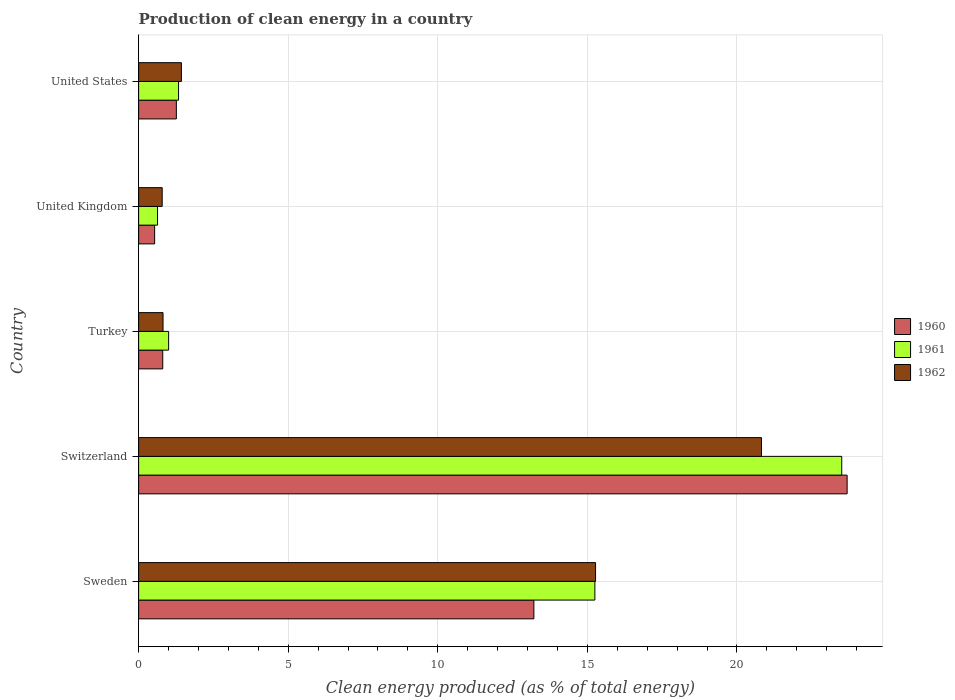How many different coloured bars are there?
Give a very brief answer. 3. Are the number of bars on each tick of the Y-axis equal?
Give a very brief answer. Yes. How many bars are there on the 4th tick from the top?
Offer a very short reply. 3. How many bars are there on the 2nd tick from the bottom?
Provide a succinct answer. 3. What is the label of the 2nd group of bars from the top?
Provide a succinct answer. United Kingdom. In how many cases, is the number of bars for a given country not equal to the number of legend labels?
Your answer should be very brief. 0. What is the percentage of clean energy produced in 1960 in United Kingdom?
Provide a short and direct response. 0.54. Across all countries, what is the maximum percentage of clean energy produced in 1961?
Provide a succinct answer. 23.5. Across all countries, what is the minimum percentage of clean energy produced in 1960?
Your response must be concise. 0.54. In which country was the percentage of clean energy produced in 1960 maximum?
Make the answer very short. Switzerland. What is the total percentage of clean energy produced in 1960 in the graph?
Your response must be concise. 39.5. What is the difference between the percentage of clean energy produced in 1962 in Sweden and that in Turkey?
Keep it short and to the point. 14.46. What is the difference between the percentage of clean energy produced in 1961 in United States and the percentage of clean energy produced in 1962 in Switzerland?
Ensure brevity in your answer.  -19.48. What is the average percentage of clean energy produced in 1960 per country?
Offer a very short reply. 7.9. What is the difference between the percentage of clean energy produced in 1962 and percentage of clean energy produced in 1961 in Switzerland?
Offer a very short reply. -2.68. In how many countries, is the percentage of clean energy produced in 1961 greater than 19 %?
Make the answer very short. 1. What is the ratio of the percentage of clean energy produced in 1961 in Sweden to that in United States?
Your answer should be compact. 11.43. What is the difference between the highest and the second highest percentage of clean energy produced in 1960?
Provide a succinct answer. 10.47. What is the difference between the highest and the lowest percentage of clean energy produced in 1960?
Offer a terse response. 23.15. In how many countries, is the percentage of clean energy produced in 1962 greater than the average percentage of clean energy produced in 1962 taken over all countries?
Provide a short and direct response. 2. Is the sum of the percentage of clean energy produced in 1960 in Sweden and United Kingdom greater than the maximum percentage of clean energy produced in 1961 across all countries?
Give a very brief answer. No. What does the 1st bar from the bottom in United States represents?
Offer a terse response. 1960. Is it the case that in every country, the sum of the percentage of clean energy produced in 1960 and percentage of clean energy produced in 1961 is greater than the percentage of clean energy produced in 1962?
Your answer should be compact. Yes. Are all the bars in the graph horizontal?
Keep it short and to the point. Yes. Are the values on the major ticks of X-axis written in scientific E-notation?
Give a very brief answer. No. Does the graph contain grids?
Your answer should be compact. Yes. How are the legend labels stacked?
Provide a succinct answer. Vertical. What is the title of the graph?
Give a very brief answer. Production of clean energy in a country. Does "1972" appear as one of the legend labels in the graph?
Keep it short and to the point. No. What is the label or title of the X-axis?
Your answer should be compact. Clean energy produced (as % of total energy). What is the label or title of the Y-axis?
Offer a very short reply. Country. What is the Clean energy produced (as % of total energy) of 1960 in Sweden?
Offer a terse response. 13.21. What is the Clean energy produced (as % of total energy) of 1961 in Sweden?
Your answer should be compact. 15.25. What is the Clean energy produced (as % of total energy) of 1962 in Sweden?
Make the answer very short. 15.27. What is the Clean energy produced (as % of total energy) in 1960 in Switzerland?
Provide a short and direct response. 23.68. What is the Clean energy produced (as % of total energy) in 1961 in Switzerland?
Your answer should be compact. 23.5. What is the Clean energy produced (as % of total energy) in 1962 in Switzerland?
Keep it short and to the point. 20.82. What is the Clean energy produced (as % of total energy) in 1960 in Turkey?
Provide a succinct answer. 0.81. What is the Clean energy produced (as % of total energy) in 1961 in Turkey?
Make the answer very short. 1. What is the Clean energy produced (as % of total energy) of 1962 in Turkey?
Ensure brevity in your answer.  0.82. What is the Clean energy produced (as % of total energy) of 1960 in United Kingdom?
Make the answer very short. 0.54. What is the Clean energy produced (as % of total energy) of 1961 in United Kingdom?
Offer a very short reply. 0.63. What is the Clean energy produced (as % of total energy) in 1962 in United Kingdom?
Make the answer very short. 0.79. What is the Clean energy produced (as % of total energy) of 1960 in United States?
Ensure brevity in your answer.  1.26. What is the Clean energy produced (as % of total energy) in 1961 in United States?
Your answer should be very brief. 1.33. What is the Clean energy produced (as % of total energy) in 1962 in United States?
Your response must be concise. 1.43. Across all countries, what is the maximum Clean energy produced (as % of total energy) in 1960?
Keep it short and to the point. 23.68. Across all countries, what is the maximum Clean energy produced (as % of total energy) of 1961?
Offer a terse response. 23.5. Across all countries, what is the maximum Clean energy produced (as % of total energy) in 1962?
Ensure brevity in your answer.  20.82. Across all countries, what is the minimum Clean energy produced (as % of total energy) of 1960?
Give a very brief answer. 0.54. Across all countries, what is the minimum Clean energy produced (as % of total energy) of 1961?
Your answer should be compact. 0.63. Across all countries, what is the minimum Clean energy produced (as % of total energy) in 1962?
Your answer should be very brief. 0.79. What is the total Clean energy produced (as % of total energy) of 1960 in the graph?
Your answer should be very brief. 39.5. What is the total Clean energy produced (as % of total energy) of 1961 in the graph?
Ensure brevity in your answer.  41.72. What is the total Clean energy produced (as % of total energy) in 1962 in the graph?
Your response must be concise. 39.12. What is the difference between the Clean energy produced (as % of total energy) in 1960 in Sweden and that in Switzerland?
Ensure brevity in your answer.  -10.47. What is the difference between the Clean energy produced (as % of total energy) in 1961 in Sweden and that in Switzerland?
Make the answer very short. -8.25. What is the difference between the Clean energy produced (as % of total energy) in 1962 in Sweden and that in Switzerland?
Provide a succinct answer. -5.55. What is the difference between the Clean energy produced (as % of total energy) of 1960 in Sweden and that in Turkey?
Provide a short and direct response. 12.4. What is the difference between the Clean energy produced (as % of total energy) of 1961 in Sweden and that in Turkey?
Offer a very short reply. 14.25. What is the difference between the Clean energy produced (as % of total energy) in 1962 in Sweden and that in Turkey?
Offer a very short reply. 14.46. What is the difference between the Clean energy produced (as % of total energy) in 1960 in Sweden and that in United Kingdom?
Offer a terse response. 12.68. What is the difference between the Clean energy produced (as % of total energy) in 1961 in Sweden and that in United Kingdom?
Offer a terse response. 14.62. What is the difference between the Clean energy produced (as % of total energy) in 1962 in Sweden and that in United Kingdom?
Make the answer very short. 14.49. What is the difference between the Clean energy produced (as % of total energy) of 1960 in Sweden and that in United States?
Keep it short and to the point. 11.95. What is the difference between the Clean energy produced (as % of total energy) of 1961 in Sweden and that in United States?
Make the answer very short. 13.92. What is the difference between the Clean energy produced (as % of total energy) in 1962 in Sweden and that in United States?
Keep it short and to the point. 13.84. What is the difference between the Clean energy produced (as % of total energy) of 1960 in Switzerland and that in Turkey?
Your response must be concise. 22.88. What is the difference between the Clean energy produced (as % of total energy) of 1961 in Switzerland and that in Turkey?
Provide a succinct answer. 22.5. What is the difference between the Clean energy produced (as % of total energy) in 1962 in Switzerland and that in Turkey?
Offer a very short reply. 20. What is the difference between the Clean energy produced (as % of total energy) in 1960 in Switzerland and that in United Kingdom?
Offer a terse response. 23.15. What is the difference between the Clean energy produced (as % of total energy) of 1961 in Switzerland and that in United Kingdom?
Your answer should be compact. 22.87. What is the difference between the Clean energy produced (as % of total energy) in 1962 in Switzerland and that in United Kingdom?
Offer a terse response. 20.03. What is the difference between the Clean energy produced (as % of total energy) of 1960 in Switzerland and that in United States?
Your answer should be compact. 22.42. What is the difference between the Clean energy produced (as % of total energy) in 1961 in Switzerland and that in United States?
Your answer should be compact. 22.17. What is the difference between the Clean energy produced (as % of total energy) of 1962 in Switzerland and that in United States?
Give a very brief answer. 19.39. What is the difference between the Clean energy produced (as % of total energy) of 1960 in Turkey and that in United Kingdom?
Provide a short and direct response. 0.27. What is the difference between the Clean energy produced (as % of total energy) of 1961 in Turkey and that in United Kingdom?
Offer a very short reply. 0.37. What is the difference between the Clean energy produced (as % of total energy) in 1962 in Turkey and that in United Kingdom?
Your answer should be compact. 0.03. What is the difference between the Clean energy produced (as % of total energy) in 1960 in Turkey and that in United States?
Make the answer very short. -0.46. What is the difference between the Clean energy produced (as % of total energy) in 1961 in Turkey and that in United States?
Your answer should be compact. -0.33. What is the difference between the Clean energy produced (as % of total energy) of 1962 in Turkey and that in United States?
Offer a terse response. -0.61. What is the difference between the Clean energy produced (as % of total energy) of 1960 in United Kingdom and that in United States?
Provide a short and direct response. -0.73. What is the difference between the Clean energy produced (as % of total energy) of 1961 in United Kingdom and that in United States?
Offer a terse response. -0.7. What is the difference between the Clean energy produced (as % of total energy) in 1962 in United Kingdom and that in United States?
Make the answer very short. -0.64. What is the difference between the Clean energy produced (as % of total energy) of 1960 in Sweden and the Clean energy produced (as % of total energy) of 1961 in Switzerland?
Your response must be concise. -10.29. What is the difference between the Clean energy produced (as % of total energy) in 1960 in Sweden and the Clean energy produced (as % of total energy) in 1962 in Switzerland?
Provide a short and direct response. -7.61. What is the difference between the Clean energy produced (as % of total energy) in 1961 in Sweden and the Clean energy produced (as % of total energy) in 1962 in Switzerland?
Make the answer very short. -5.57. What is the difference between the Clean energy produced (as % of total energy) of 1960 in Sweden and the Clean energy produced (as % of total energy) of 1961 in Turkey?
Keep it short and to the point. 12.21. What is the difference between the Clean energy produced (as % of total energy) of 1960 in Sweden and the Clean energy produced (as % of total energy) of 1962 in Turkey?
Offer a very short reply. 12.4. What is the difference between the Clean energy produced (as % of total energy) of 1961 in Sweden and the Clean energy produced (as % of total energy) of 1962 in Turkey?
Give a very brief answer. 14.43. What is the difference between the Clean energy produced (as % of total energy) in 1960 in Sweden and the Clean energy produced (as % of total energy) in 1961 in United Kingdom?
Your response must be concise. 12.58. What is the difference between the Clean energy produced (as % of total energy) of 1960 in Sweden and the Clean energy produced (as % of total energy) of 1962 in United Kingdom?
Ensure brevity in your answer.  12.42. What is the difference between the Clean energy produced (as % of total energy) in 1961 in Sweden and the Clean energy produced (as % of total energy) in 1962 in United Kingdom?
Your answer should be compact. 14.46. What is the difference between the Clean energy produced (as % of total energy) in 1960 in Sweden and the Clean energy produced (as % of total energy) in 1961 in United States?
Provide a succinct answer. 11.88. What is the difference between the Clean energy produced (as % of total energy) in 1960 in Sweden and the Clean energy produced (as % of total energy) in 1962 in United States?
Make the answer very short. 11.78. What is the difference between the Clean energy produced (as % of total energy) in 1961 in Sweden and the Clean energy produced (as % of total energy) in 1962 in United States?
Make the answer very short. 13.82. What is the difference between the Clean energy produced (as % of total energy) in 1960 in Switzerland and the Clean energy produced (as % of total energy) in 1961 in Turkey?
Offer a very short reply. 22.68. What is the difference between the Clean energy produced (as % of total energy) in 1960 in Switzerland and the Clean energy produced (as % of total energy) in 1962 in Turkey?
Ensure brevity in your answer.  22.87. What is the difference between the Clean energy produced (as % of total energy) in 1961 in Switzerland and the Clean energy produced (as % of total energy) in 1962 in Turkey?
Keep it short and to the point. 22.69. What is the difference between the Clean energy produced (as % of total energy) of 1960 in Switzerland and the Clean energy produced (as % of total energy) of 1961 in United Kingdom?
Your answer should be very brief. 23.05. What is the difference between the Clean energy produced (as % of total energy) in 1960 in Switzerland and the Clean energy produced (as % of total energy) in 1962 in United Kingdom?
Keep it short and to the point. 22.89. What is the difference between the Clean energy produced (as % of total energy) of 1961 in Switzerland and the Clean energy produced (as % of total energy) of 1962 in United Kingdom?
Keep it short and to the point. 22.71. What is the difference between the Clean energy produced (as % of total energy) in 1960 in Switzerland and the Clean energy produced (as % of total energy) in 1961 in United States?
Your response must be concise. 22.35. What is the difference between the Clean energy produced (as % of total energy) in 1960 in Switzerland and the Clean energy produced (as % of total energy) in 1962 in United States?
Ensure brevity in your answer.  22.25. What is the difference between the Clean energy produced (as % of total energy) of 1961 in Switzerland and the Clean energy produced (as % of total energy) of 1962 in United States?
Ensure brevity in your answer.  22.07. What is the difference between the Clean energy produced (as % of total energy) of 1960 in Turkey and the Clean energy produced (as % of total energy) of 1961 in United Kingdom?
Give a very brief answer. 0.17. What is the difference between the Clean energy produced (as % of total energy) in 1960 in Turkey and the Clean energy produced (as % of total energy) in 1962 in United Kingdom?
Give a very brief answer. 0.02. What is the difference between the Clean energy produced (as % of total energy) of 1961 in Turkey and the Clean energy produced (as % of total energy) of 1962 in United Kingdom?
Provide a succinct answer. 0.21. What is the difference between the Clean energy produced (as % of total energy) in 1960 in Turkey and the Clean energy produced (as % of total energy) in 1961 in United States?
Keep it short and to the point. -0.53. What is the difference between the Clean energy produced (as % of total energy) of 1960 in Turkey and the Clean energy produced (as % of total energy) of 1962 in United States?
Offer a terse response. -0.62. What is the difference between the Clean energy produced (as % of total energy) in 1961 in Turkey and the Clean energy produced (as % of total energy) in 1962 in United States?
Give a very brief answer. -0.43. What is the difference between the Clean energy produced (as % of total energy) of 1960 in United Kingdom and the Clean energy produced (as % of total energy) of 1961 in United States?
Provide a succinct answer. -0.8. What is the difference between the Clean energy produced (as % of total energy) of 1960 in United Kingdom and the Clean energy produced (as % of total energy) of 1962 in United States?
Your answer should be compact. -0.89. What is the difference between the Clean energy produced (as % of total energy) of 1961 in United Kingdom and the Clean energy produced (as % of total energy) of 1962 in United States?
Your answer should be very brief. -0.8. What is the average Clean energy produced (as % of total energy) in 1960 per country?
Offer a terse response. 7.9. What is the average Clean energy produced (as % of total energy) in 1961 per country?
Keep it short and to the point. 8.34. What is the average Clean energy produced (as % of total energy) in 1962 per country?
Give a very brief answer. 7.83. What is the difference between the Clean energy produced (as % of total energy) of 1960 and Clean energy produced (as % of total energy) of 1961 in Sweden?
Give a very brief answer. -2.04. What is the difference between the Clean energy produced (as % of total energy) in 1960 and Clean energy produced (as % of total energy) in 1962 in Sweden?
Provide a succinct answer. -2.06. What is the difference between the Clean energy produced (as % of total energy) in 1961 and Clean energy produced (as % of total energy) in 1962 in Sweden?
Give a very brief answer. -0.02. What is the difference between the Clean energy produced (as % of total energy) of 1960 and Clean energy produced (as % of total energy) of 1961 in Switzerland?
Offer a terse response. 0.18. What is the difference between the Clean energy produced (as % of total energy) of 1960 and Clean energy produced (as % of total energy) of 1962 in Switzerland?
Your answer should be compact. 2.86. What is the difference between the Clean energy produced (as % of total energy) in 1961 and Clean energy produced (as % of total energy) in 1962 in Switzerland?
Make the answer very short. 2.68. What is the difference between the Clean energy produced (as % of total energy) in 1960 and Clean energy produced (as % of total energy) in 1961 in Turkey?
Give a very brief answer. -0.2. What is the difference between the Clean energy produced (as % of total energy) in 1960 and Clean energy produced (as % of total energy) in 1962 in Turkey?
Provide a succinct answer. -0.01. What is the difference between the Clean energy produced (as % of total energy) in 1961 and Clean energy produced (as % of total energy) in 1962 in Turkey?
Ensure brevity in your answer.  0.19. What is the difference between the Clean energy produced (as % of total energy) in 1960 and Clean energy produced (as % of total energy) in 1961 in United Kingdom?
Make the answer very short. -0.1. What is the difference between the Clean energy produced (as % of total energy) in 1960 and Clean energy produced (as % of total energy) in 1962 in United Kingdom?
Give a very brief answer. -0.25. What is the difference between the Clean energy produced (as % of total energy) of 1961 and Clean energy produced (as % of total energy) of 1962 in United Kingdom?
Offer a very short reply. -0.16. What is the difference between the Clean energy produced (as % of total energy) in 1960 and Clean energy produced (as % of total energy) in 1961 in United States?
Provide a succinct answer. -0.07. What is the difference between the Clean energy produced (as % of total energy) in 1960 and Clean energy produced (as % of total energy) in 1962 in United States?
Offer a terse response. -0.17. What is the difference between the Clean energy produced (as % of total energy) of 1961 and Clean energy produced (as % of total energy) of 1962 in United States?
Provide a short and direct response. -0.1. What is the ratio of the Clean energy produced (as % of total energy) in 1960 in Sweden to that in Switzerland?
Keep it short and to the point. 0.56. What is the ratio of the Clean energy produced (as % of total energy) of 1961 in Sweden to that in Switzerland?
Provide a succinct answer. 0.65. What is the ratio of the Clean energy produced (as % of total energy) in 1962 in Sweden to that in Switzerland?
Provide a short and direct response. 0.73. What is the ratio of the Clean energy produced (as % of total energy) in 1960 in Sweden to that in Turkey?
Your answer should be very brief. 16.39. What is the ratio of the Clean energy produced (as % of total energy) of 1961 in Sweden to that in Turkey?
Keep it short and to the point. 15.21. What is the ratio of the Clean energy produced (as % of total energy) of 1962 in Sweden to that in Turkey?
Your answer should be very brief. 18.73. What is the ratio of the Clean energy produced (as % of total energy) of 1960 in Sweden to that in United Kingdom?
Ensure brevity in your answer.  24.68. What is the ratio of the Clean energy produced (as % of total energy) in 1961 in Sweden to that in United Kingdom?
Your answer should be very brief. 24.15. What is the ratio of the Clean energy produced (as % of total energy) in 1962 in Sweden to that in United Kingdom?
Your answer should be compact. 19.39. What is the ratio of the Clean energy produced (as % of total energy) in 1960 in Sweden to that in United States?
Offer a very short reply. 10.47. What is the ratio of the Clean energy produced (as % of total energy) of 1961 in Sweden to that in United States?
Your response must be concise. 11.43. What is the ratio of the Clean energy produced (as % of total energy) in 1962 in Sweden to that in United States?
Offer a very short reply. 10.68. What is the ratio of the Clean energy produced (as % of total energy) of 1960 in Switzerland to that in Turkey?
Provide a short and direct response. 29.38. What is the ratio of the Clean energy produced (as % of total energy) of 1961 in Switzerland to that in Turkey?
Ensure brevity in your answer.  23.44. What is the ratio of the Clean energy produced (as % of total energy) of 1962 in Switzerland to that in Turkey?
Keep it short and to the point. 25.53. What is the ratio of the Clean energy produced (as % of total energy) of 1960 in Switzerland to that in United Kingdom?
Give a very brief answer. 44.24. What is the ratio of the Clean energy produced (as % of total energy) of 1961 in Switzerland to that in United Kingdom?
Your answer should be compact. 37.21. What is the ratio of the Clean energy produced (as % of total energy) of 1962 in Switzerland to that in United Kingdom?
Make the answer very short. 26.43. What is the ratio of the Clean energy produced (as % of total energy) in 1960 in Switzerland to that in United States?
Your answer should be compact. 18.78. What is the ratio of the Clean energy produced (as % of total energy) of 1961 in Switzerland to that in United States?
Your answer should be compact. 17.61. What is the ratio of the Clean energy produced (as % of total energy) in 1962 in Switzerland to that in United States?
Make the answer very short. 14.56. What is the ratio of the Clean energy produced (as % of total energy) in 1960 in Turkey to that in United Kingdom?
Your response must be concise. 1.51. What is the ratio of the Clean energy produced (as % of total energy) in 1961 in Turkey to that in United Kingdom?
Your answer should be very brief. 1.59. What is the ratio of the Clean energy produced (as % of total energy) of 1962 in Turkey to that in United Kingdom?
Make the answer very short. 1.04. What is the ratio of the Clean energy produced (as % of total energy) of 1960 in Turkey to that in United States?
Keep it short and to the point. 0.64. What is the ratio of the Clean energy produced (as % of total energy) of 1961 in Turkey to that in United States?
Offer a very short reply. 0.75. What is the ratio of the Clean energy produced (as % of total energy) in 1962 in Turkey to that in United States?
Offer a terse response. 0.57. What is the ratio of the Clean energy produced (as % of total energy) in 1960 in United Kingdom to that in United States?
Provide a short and direct response. 0.42. What is the ratio of the Clean energy produced (as % of total energy) in 1961 in United Kingdom to that in United States?
Ensure brevity in your answer.  0.47. What is the ratio of the Clean energy produced (as % of total energy) in 1962 in United Kingdom to that in United States?
Give a very brief answer. 0.55. What is the difference between the highest and the second highest Clean energy produced (as % of total energy) of 1960?
Provide a short and direct response. 10.47. What is the difference between the highest and the second highest Clean energy produced (as % of total energy) of 1961?
Your answer should be very brief. 8.25. What is the difference between the highest and the second highest Clean energy produced (as % of total energy) of 1962?
Keep it short and to the point. 5.55. What is the difference between the highest and the lowest Clean energy produced (as % of total energy) in 1960?
Ensure brevity in your answer.  23.15. What is the difference between the highest and the lowest Clean energy produced (as % of total energy) of 1961?
Offer a very short reply. 22.87. What is the difference between the highest and the lowest Clean energy produced (as % of total energy) in 1962?
Make the answer very short. 20.03. 